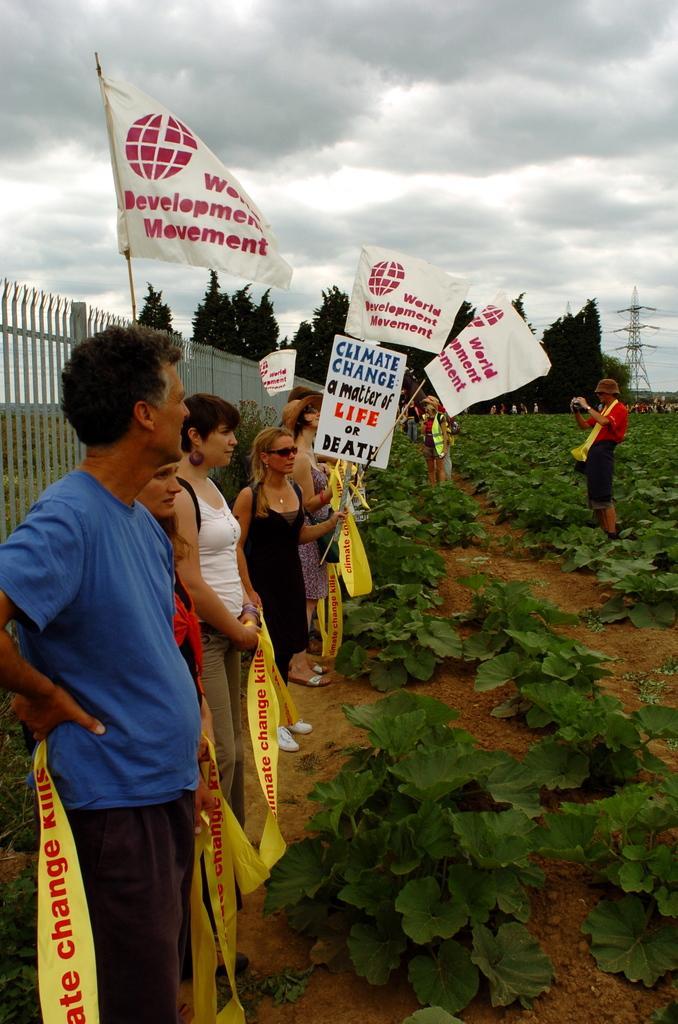In one or two sentences, can you explain what this image depicts? In this image we can see a group of people standing and protesting, a few among them are holding flags and banners which contains text in it, there is a fence behind them and a person is taking a photo in front of them, in the background there trees, plants and a current pole. 